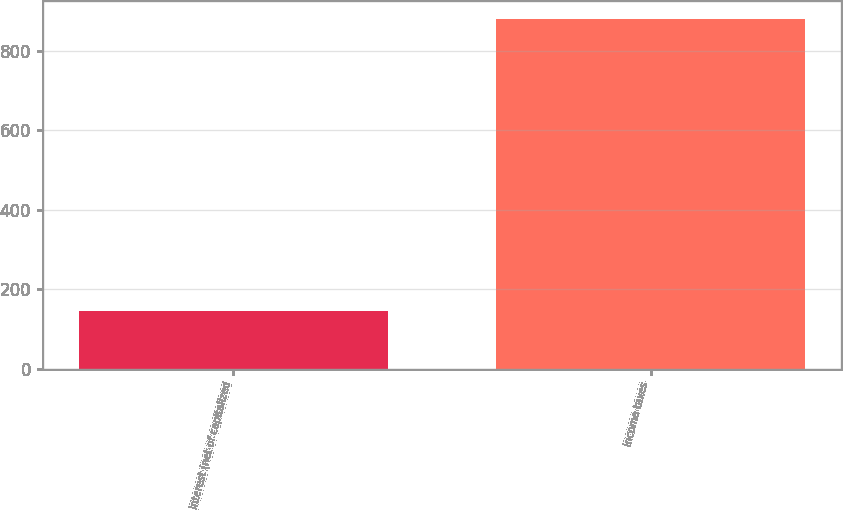Convert chart to OTSL. <chart><loc_0><loc_0><loc_500><loc_500><bar_chart><fcel>Interest (net of capitalized<fcel>Income taxes<nl><fcel>145<fcel>880<nl></chart> 